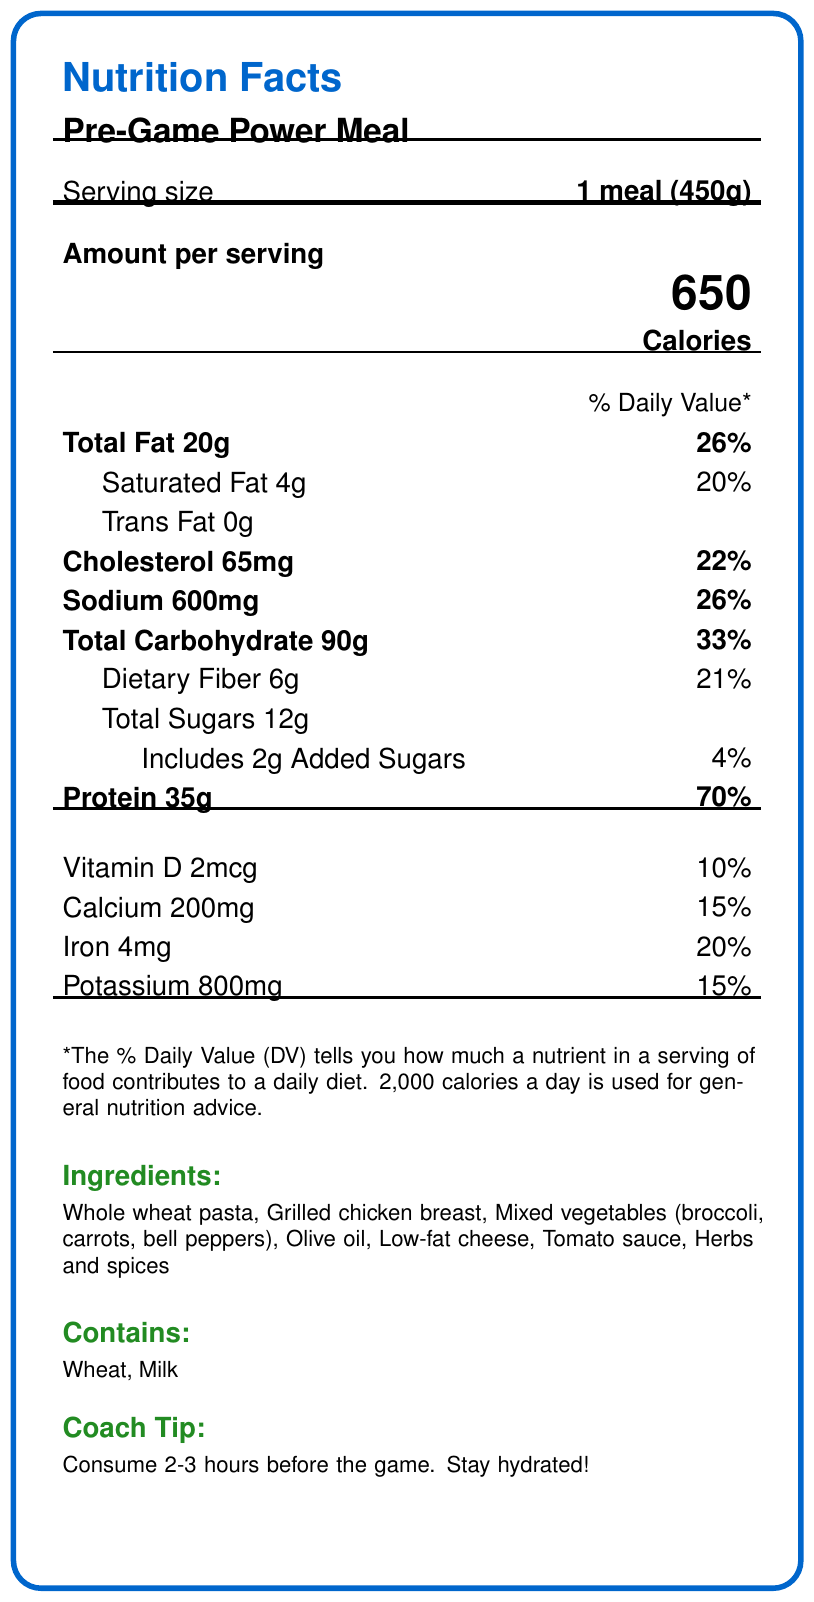What is the serving size of the Pre-Game Power Meal? The serving size is clearly stated near the top of the document as "1 meal (450g)".
Answer: 1 meal (450g) How many calories are in one serving of the Pre-Game Power Meal? The calories per serving are listed prominently as "650" next to the "Calories" label.
Answer: 650 calories What percentage of the daily value of protein does the Pre-Game Power Meal provide? The protein value is listed as "35g" and its daily value percentage is "70%".
Answer: 70% How much total fat is in one serving of the Pre-Game Power Meal? The total fat per serving is stated as "Total Fat 20g".
Answer: 20g What are the main ingredients of the Pre-Game Power Meal? The ingredients are listed under the "Ingredients" section.
Answer: Whole wheat pasta, Grilled chicken breast, Mixed vegetables (broccoli, carrots, bell peppers), Olive oil, Low-fat cheese, Tomato sauce, Herbs and spices Which of the following allergens are present in the Pre-Game Power Meal? A. Soy B. Eggs C. Wheat D. Nuts The allergens listed are "Wheat" and "Milk", making Wheat the correct answer.
Answer: C. Wheat How much dietary fiber does one meal contain? The dietary fiber content is listed as "Dietary Fiber 6g".
Answer: 6g What is the recommended time for athletes to consume the Pre-Game Power Meal before the game? A. 1 hour B. 2-3 hours C. 30 minutes D. As soon as possible The "Coach Tip" section advises consuming the meal 2-3 hours before the game.
Answer: B. 2-3 hours True or False: The Pre-Game Power Meal contains added sugars. The document states that the meal includes "2g Added Sugars".
Answer: True What are the three main components of the meal? The meal components section lists these three items and their respective amounts.
Answer: Whole wheat pasta with grilled chicken (250g), Steamed mixed vegetables (150g), Low-fat fruit yogurt (150g) Summarize the purpose and design of the Pre-Game Power Meal. The summary is based on the nutritionist's note, which highlights the meal's purpose, and the coach's tip that offers practical advice.
Answer: The Pre-Game Power Meal is designed to provide high school athletes with a balanced mix of complex carbohydrates, lean protein, and healthy fats to fuel optimal performance. It includes ingredients like whole wheat pasta, grilled chicken, and mixed vegetables to sustain endurance. Athletes are encouraged to eat this meal 2-3 hours before the game and stay hydrated. What is the total amount of potassium provided by the Pre-Game Power Meal? The potassium content is listed as "Potassium 800mg".
Answer: 800mg Can we determine the exact recipe for the Pre-Game Power Meal from this document? The document lists the main ingredients but does not provide detailed cooking instructions or exact proportions for the recipe.
Answer: Not enough information 